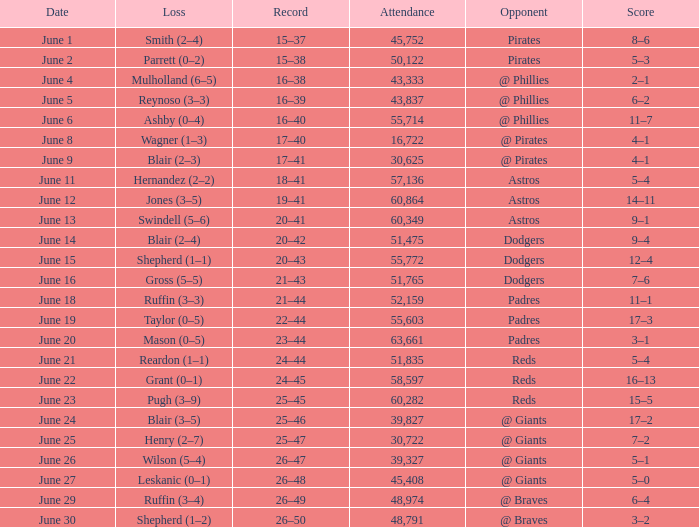What was the outcome on june 12? 14–11. Would you mind parsing the complete table? {'header': ['Date', 'Loss', 'Record', 'Attendance', 'Opponent', 'Score'], 'rows': [['June 1', 'Smith (2–4)', '15–37', '45,752', 'Pirates', '8–6'], ['June 2', 'Parrett (0–2)', '15–38', '50,122', 'Pirates', '5–3'], ['June 4', 'Mulholland (6–5)', '16–38', '43,333', '@ Phillies', '2–1'], ['June 5', 'Reynoso (3–3)', '16–39', '43,837', '@ Phillies', '6–2'], ['June 6', 'Ashby (0–4)', '16–40', '55,714', '@ Phillies', '11–7'], ['June 8', 'Wagner (1–3)', '17–40', '16,722', '@ Pirates', '4–1'], ['June 9', 'Blair (2–3)', '17–41', '30,625', '@ Pirates', '4–1'], ['June 11', 'Hernandez (2–2)', '18–41', '57,136', 'Astros', '5–4'], ['June 12', 'Jones (3–5)', '19–41', '60,864', 'Astros', '14–11'], ['June 13', 'Swindell (5–6)', '20–41', '60,349', 'Astros', '9–1'], ['June 14', 'Blair (2–4)', '20–42', '51,475', 'Dodgers', '9–4'], ['June 15', 'Shepherd (1–1)', '20–43', '55,772', 'Dodgers', '12–4'], ['June 16', 'Gross (5–5)', '21–43', '51,765', 'Dodgers', '7–6'], ['June 18', 'Ruffin (3–3)', '21–44', '52,159', 'Padres', '11–1'], ['June 19', 'Taylor (0–5)', '22–44', '55,603', 'Padres', '17–3'], ['June 20', 'Mason (0–5)', '23–44', '63,661', 'Padres', '3–1'], ['June 21', 'Reardon (1–1)', '24–44', '51,835', 'Reds', '5–4'], ['June 22', 'Grant (0–1)', '24–45', '58,597', 'Reds', '16–13'], ['June 23', 'Pugh (3–9)', '25–45', '60,282', 'Reds', '15–5'], ['June 24', 'Blair (3–5)', '25–46', '39,827', '@ Giants', '17–2'], ['June 25', 'Henry (2–7)', '25–47', '30,722', '@ Giants', '7–2'], ['June 26', 'Wilson (5–4)', '26–47', '39,327', '@ Giants', '5–1'], ['June 27', 'Leskanic (0–1)', '26–48', '45,408', '@ Giants', '5–0'], ['June 29', 'Ruffin (3–4)', '26–49', '48,974', '@ Braves', '6–4'], ['June 30', 'Shepherd (1–2)', '26–50', '48,791', '@ Braves', '3–2']]} 